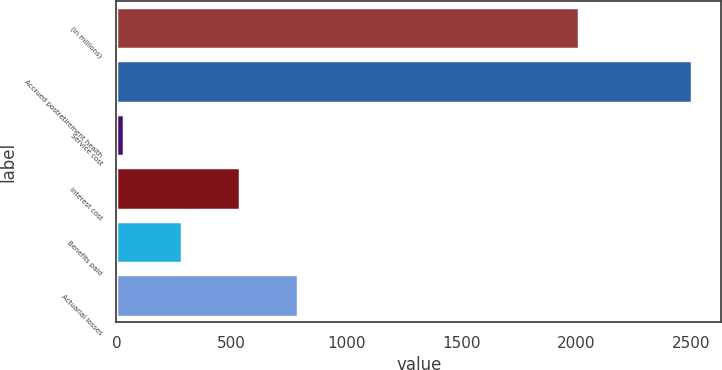Convert chart. <chart><loc_0><loc_0><loc_500><loc_500><bar_chart><fcel>(in millions)<fcel>Accrued postretirement health<fcel>Service cost<fcel>Interest cost<fcel>Benefits paid<fcel>Actuarial losses<nl><fcel>2011<fcel>2505<fcel>34<fcel>536.8<fcel>285.4<fcel>788.2<nl></chart> 